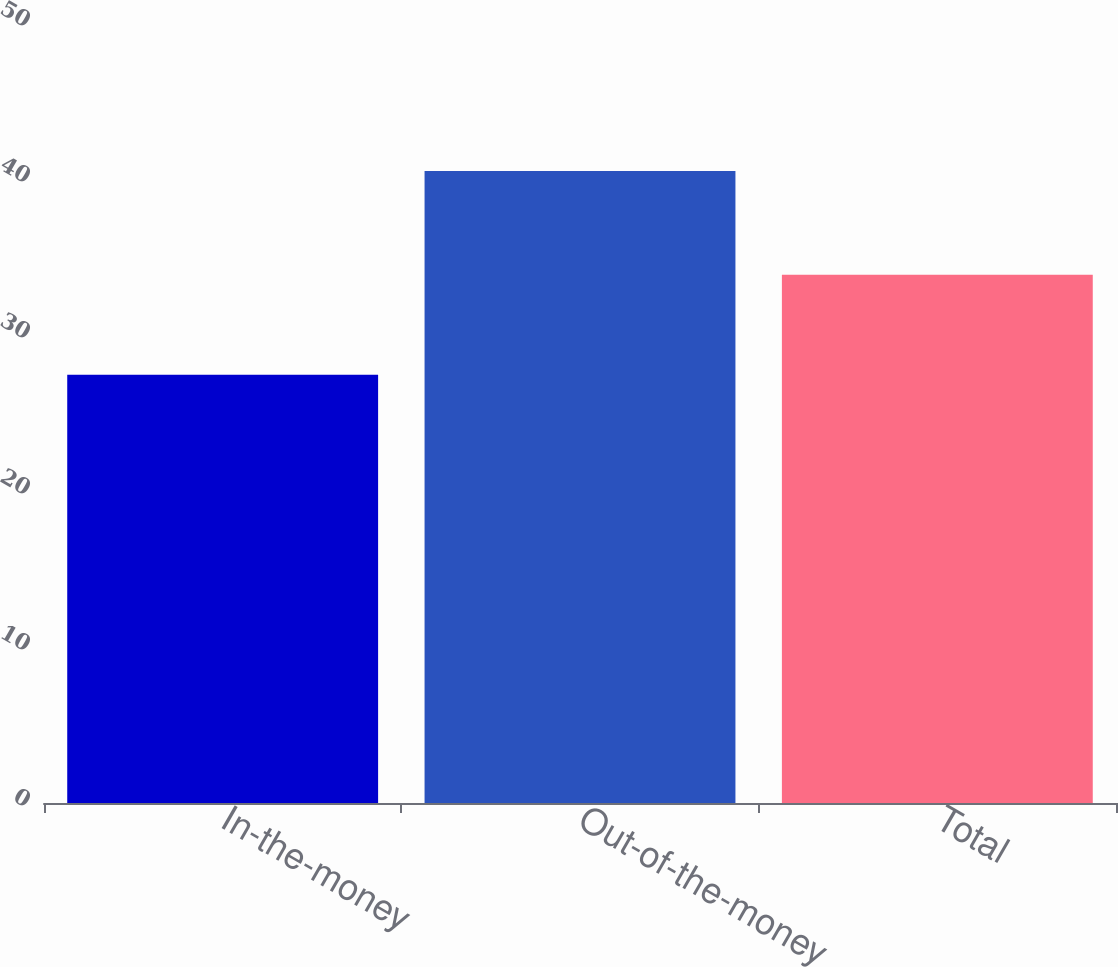<chart> <loc_0><loc_0><loc_500><loc_500><bar_chart><fcel>In-the-money<fcel>Out-of-the-money<fcel>Total<nl><fcel>27.45<fcel>40.51<fcel>33.87<nl></chart> 